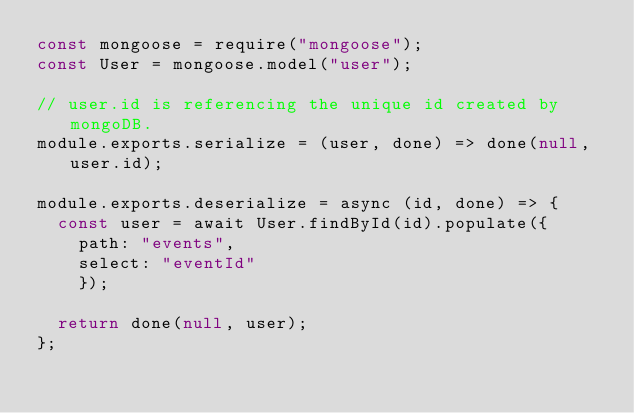<code> <loc_0><loc_0><loc_500><loc_500><_JavaScript_>const mongoose = require("mongoose");
const User = mongoose.model("user");

// user.id is referencing the unique id created by mongoDB.
module.exports.serialize = (user, done) => done(null, user.id);

module.exports.deserialize = async (id, done) => {
  const user = await User.findById(id).populate({
    path: "events",
    select: "eventId"
	});

  return done(null, user);
};
</code> 